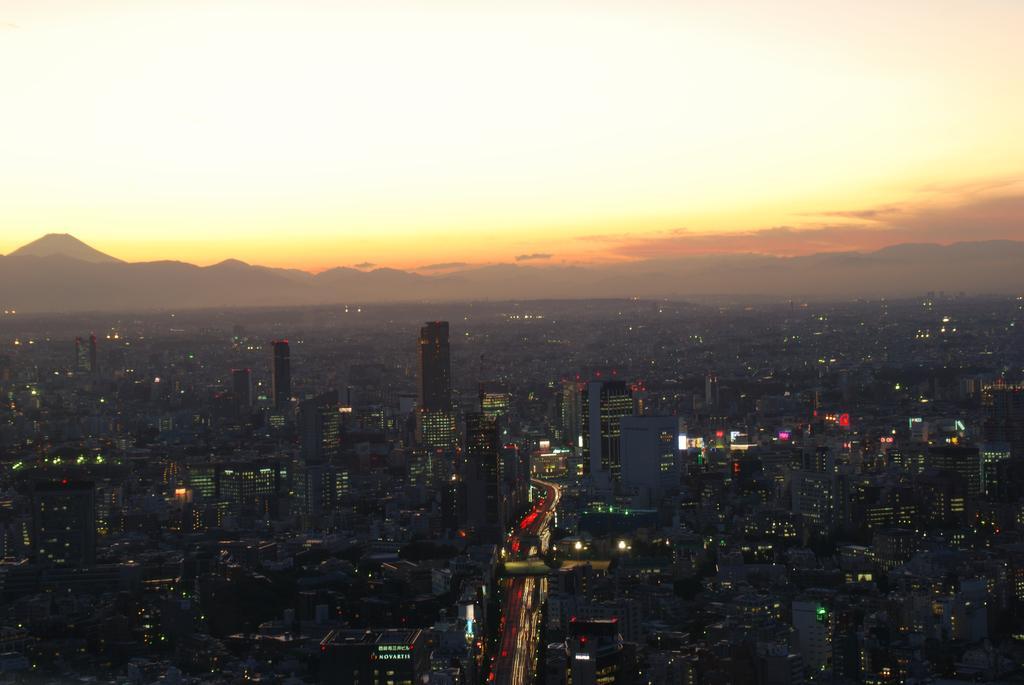Could you give a brief overview of what you see in this image? In this picture we can see buildings, lights and hills. 